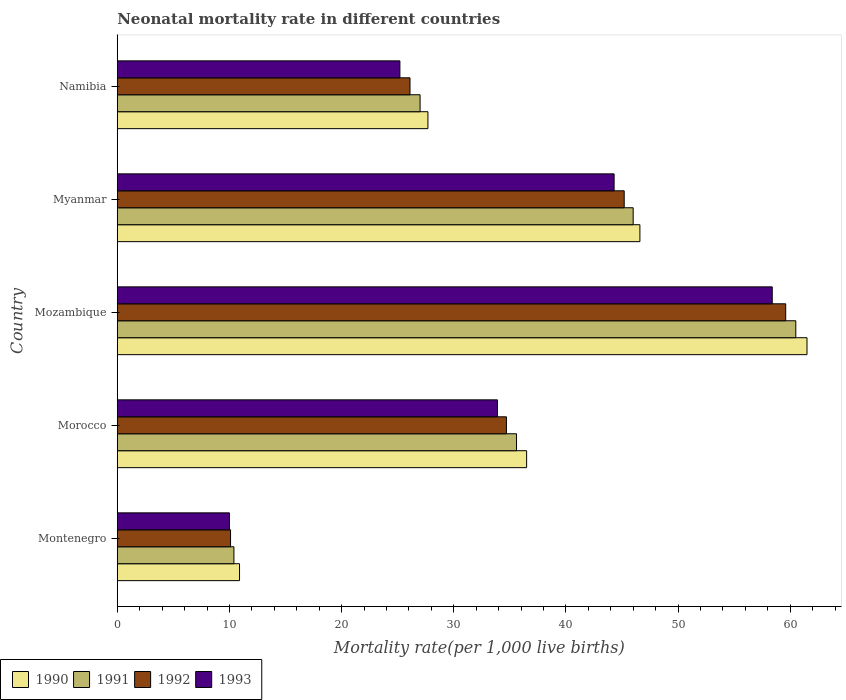How many different coloured bars are there?
Your answer should be very brief. 4. How many groups of bars are there?
Your answer should be compact. 5. Are the number of bars on each tick of the Y-axis equal?
Provide a short and direct response. Yes. How many bars are there on the 5th tick from the top?
Offer a terse response. 4. What is the label of the 4th group of bars from the top?
Ensure brevity in your answer.  Morocco. In how many cases, is the number of bars for a given country not equal to the number of legend labels?
Offer a very short reply. 0. What is the neonatal mortality rate in 1993 in Mozambique?
Ensure brevity in your answer.  58.4. Across all countries, what is the maximum neonatal mortality rate in 1990?
Ensure brevity in your answer.  61.5. Across all countries, what is the minimum neonatal mortality rate in 1993?
Provide a short and direct response. 10. In which country was the neonatal mortality rate in 1990 maximum?
Provide a succinct answer. Mozambique. In which country was the neonatal mortality rate in 1992 minimum?
Provide a short and direct response. Montenegro. What is the total neonatal mortality rate in 1993 in the graph?
Provide a short and direct response. 171.8. What is the difference between the neonatal mortality rate in 1991 in Myanmar and that in Namibia?
Make the answer very short. 19. What is the difference between the neonatal mortality rate in 1992 in Myanmar and the neonatal mortality rate in 1991 in Montenegro?
Your response must be concise. 34.8. What is the average neonatal mortality rate in 1991 per country?
Make the answer very short. 35.9. What is the difference between the neonatal mortality rate in 1993 and neonatal mortality rate in 1991 in Montenegro?
Your answer should be compact. -0.4. What is the ratio of the neonatal mortality rate in 1993 in Montenegro to that in Namibia?
Your answer should be compact. 0.4. Is the neonatal mortality rate in 1991 in Montenegro less than that in Namibia?
Ensure brevity in your answer.  Yes. Is the difference between the neonatal mortality rate in 1993 in Montenegro and Myanmar greater than the difference between the neonatal mortality rate in 1991 in Montenegro and Myanmar?
Your answer should be very brief. Yes. What is the difference between the highest and the second highest neonatal mortality rate in 1992?
Offer a very short reply. 14.4. What is the difference between the highest and the lowest neonatal mortality rate in 1991?
Offer a terse response. 50.1. Is the sum of the neonatal mortality rate in 1993 in Mozambique and Namibia greater than the maximum neonatal mortality rate in 1992 across all countries?
Offer a terse response. Yes. Is it the case that in every country, the sum of the neonatal mortality rate in 1990 and neonatal mortality rate in 1992 is greater than the sum of neonatal mortality rate in 1991 and neonatal mortality rate in 1993?
Your response must be concise. No. What does the 1st bar from the top in Namibia represents?
Provide a succinct answer. 1993. What does the 4th bar from the bottom in Mozambique represents?
Your answer should be very brief. 1993. Is it the case that in every country, the sum of the neonatal mortality rate in 1991 and neonatal mortality rate in 1990 is greater than the neonatal mortality rate in 1992?
Provide a succinct answer. Yes. How many bars are there?
Your response must be concise. 20. Are all the bars in the graph horizontal?
Ensure brevity in your answer.  Yes. What is the difference between two consecutive major ticks on the X-axis?
Offer a terse response. 10. Does the graph contain any zero values?
Offer a very short reply. No. Does the graph contain grids?
Your response must be concise. No. How many legend labels are there?
Your answer should be very brief. 4. How are the legend labels stacked?
Offer a terse response. Horizontal. What is the title of the graph?
Make the answer very short. Neonatal mortality rate in different countries. Does "1985" appear as one of the legend labels in the graph?
Offer a very short reply. No. What is the label or title of the X-axis?
Provide a succinct answer. Mortality rate(per 1,0 live births). What is the label or title of the Y-axis?
Keep it short and to the point. Country. What is the Mortality rate(per 1,000 live births) in 1990 in Montenegro?
Your answer should be compact. 10.9. What is the Mortality rate(per 1,000 live births) in 1992 in Montenegro?
Provide a short and direct response. 10.1. What is the Mortality rate(per 1,000 live births) of 1993 in Montenegro?
Your answer should be compact. 10. What is the Mortality rate(per 1,000 live births) in 1990 in Morocco?
Keep it short and to the point. 36.5. What is the Mortality rate(per 1,000 live births) in 1991 in Morocco?
Give a very brief answer. 35.6. What is the Mortality rate(per 1,000 live births) in 1992 in Morocco?
Your answer should be compact. 34.7. What is the Mortality rate(per 1,000 live births) of 1993 in Morocco?
Keep it short and to the point. 33.9. What is the Mortality rate(per 1,000 live births) in 1990 in Mozambique?
Your answer should be very brief. 61.5. What is the Mortality rate(per 1,000 live births) of 1991 in Mozambique?
Your response must be concise. 60.5. What is the Mortality rate(per 1,000 live births) in 1992 in Mozambique?
Your response must be concise. 59.6. What is the Mortality rate(per 1,000 live births) of 1993 in Mozambique?
Offer a very short reply. 58.4. What is the Mortality rate(per 1,000 live births) in 1990 in Myanmar?
Ensure brevity in your answer.  46.6. What is the Mortality rate(per 1,000 live births) in 1992 in Myanmar?
Provide a succinct answer. 45.2. What is the Mortality rate(per 1,000 live births) in 1993 in Myanmar?
Make the answer very short. 44.3. What is the Mortality rate(per 1,000 live births) in 1990 in Namibia?
Your answer should be compact. 27.7. What is the Mortality rate(per 1,000 live births) in 1991 in Namibia?
Give a very brief answer. 27. What is the Mortality rate(per 1,000 live births) of 1992 in Namibia?
Your answer should be very brief. 26.1. What is the Mortality rate(per 1,000 live births) in 1993 in Namibia?
Offer a very short reply. 25.2. Across all countries, what is the maximum Mortality rate(per 1,000 live births) of 1990?
Ensure brevity in your answer.  61.5. Across all countries, what is the maximum Mortality rate(per 1,000 live births) in 1991?
Your answer should be compact. 60.5. Across all countries, what is the maximum Mortality rate(per 1,000 live births) of 1992?
Your answer should be very brief. 59.6. Across all countries, what is the maximum Mortality rate(per 1,000 live births) in 1993?
Ensure brevity in your answer.  58.4. What is the total Mortality rate(per 1,000 live births) in 1990 in the graph?
Provide a short and direct response. 183.2. What is the total Mortality rate(per 1,000 live births) in 1991 in the graph?
Your answer should be very brief. 179.5. What is the total Mortality rate(per 1,000 live births) of 1992 in the graph?
Offer a terse response. 175.7. What is the total Mortality rate(per 1,000 live births) in 1993 in the graph?
Ensure brevity in your answer.  171.8. What is the difference between the Mortality rate(per 1,000 live births) in 1990 in Montenegro and that in Morocco?
Offer a very short reply. -25.6. What is the difference between the Mortality rate(per 1,000 live births) in 1991 in Montenegro and that in Morocco?
Ensure brevity in your answer.  -25.2. What is the difference between the Mortality rate(per 1,000 live births) of 1992 in Montenegro and that in Morocco?
Make the answer very short. -24.6. What is the difference between the Mortality rate(per 1,000 live births) of 1993 in Montenegro and that in Morocco?
Provide a succinct answer. -23.9. What is the difference between the Mortality rate(per 1,000 live births) in 1990 in Montenegro and that in Mozambique?
Give a very brief answer. -50.6. What is the difference between the Mortality rate(per 1,000 live births) of 1991 in Montenegro and that in Mozambique?
Ensure brevity in your answer.  -50.1. What is the difference between the Mortality rate(per 1,000 live births) of 1992 in Montenegro and that in Mozambique?
Ensure brevity in your answer.  -49.5. What is the difference between the Mortality rate(per 1,000 live births) of 1993 in Montenegro and that in Mozambique?
Your response must be concise. -48.4. What is the difference between the Mortality rate(per 1,000 live births) of 1990 in Montenegro and that in Myanmar?
Provide a succinct answer. -35.7. What is the difference between the Mortality rate(per 1,000 live births) in 1991 in Montenegro and that in Myanmar?
Offer a very short reply. -35.6. What is the difference between the Mortality rate(per 1,000 live births) of 1992 in Montenegro and that in Myanmar?
Your response must be concise. -35.1. What is the difference between the Mortality rate(per 1,000 live births) in 1993 in Montenegro and that in Myanmar?
Your answer should be very brief. -34.3. What is the difference between the Mortality rate(per 1,000 live births) of 1990 in Montenegro and that in Namibia?
Ensure brevity in your answer.  -16.8. What is the difference between the Mortality rate(per 1,000 live births) of 1991 in Montenegro and that in Namibia?
Provide a short and direct response. -16.6. What is the difference between the Mortality rate(per 1,000 live births) in 1993 in Montenegro and that in Namibia?
Provide a short and direct response. -15.2. What is the difference between the Mortality rate(per 1,000 live births) in 1990 in Morocco and that in Mozambique?
Keep it short and to the point. -25. What is the difference between the Mortality rate(per 1,000 live births) of 1991 in Morocco and that in Mozambique?
Offer a terse response. -24.9. What is the difference between the Mortality rate(per 1,000 live births) in 1992 in Morocco and that in Mozambique?
Make the answer very short. -24.9. What is the difference between the Mortality rate(per 1,000 live births) of 1993 in Morocco and that in Mozambique?
Your answer should be very brief. -24.5. What is the difference between the Mortality rate(per 1,000 live births) of 1991 in Morocco and that in Myanmar?
Provide a short and direct response. -10.4. What is the difference between the Mortality rate(per 1,000 live births) of 1992 in Morocco and that in Myanmar?
Provide a succinct answer. -10.5. What is the difference between the Mortality rate(per 1,000 live births) in 1993 in Morocco and that in Myanmar?
Your answer should be compact. -10.4. What is the difference between the Mortality rate(per 1,000 live births) in 1990 in Morocco and that in Namibia?
Ensure brevity in your answer.  8.8. What is the difference between the Mortality rate(per 1,000 live births) of 1991 in Morocco and that in Namibia?
Your answer should be compact. 8.6. What is the difference between the Mortality rate(per 1,000 live births) in 1992 in Morocco and that in Namibia?
Provide a succinct answer. 8.6. What is the difference between the Mortality rate(per 1,000 live births) of 1990 in Mozambique and that in Myanmar?
Your answer should be very brief. 14.9. What is the difference between the Mortality rate(per 1,000 live births) in 1991 in Mozambique and that in Myanmar?
Offer a terse response. 14.5. What is the difference between the Mortality rate(per 1,000 live births) of 1993 in Mozambique and that in Myanmar?
Offer a very short reply. 14.1. What is the difference between the Mortality rate(per 1,000 live births) of 1990 in Mozambique and that in Namibia?
Your answer should be compact. 33.8. What is the difference between the Mortality rate(per 1,000 live births) in 1991 in Mozambique and that in Namibia?
Provide a short and direct response. 33.5. What is the difference between the Mortality rate(per 1,000 live births) in 1992 in Mozambique and that in Namibia?
Provide a succinct answer. 33.5. What is the difference between the Mortality rate(per 1,000 live births) of 1993 in Mozambique and that in Namibia?
Your answer should be very brief. 33.2. What is the difference between the Mortality rate(per 1,000 live births) in 1990 in Myanmar and that in Namibia?
Your answer should be compact. 18.9. What is the difference between the Mortality rate(per 1,000 live births) in 1991 in Myanmar and that in Namibia?
Ensure brevity in your answer.  19. What is the difference between the Mortality rate(per 1,000 live births) in 1993 in Myanmar and that in Namibia?
Your response must be concise. 19.1. What is the difference between the Mortality rate(per 1,000 live births) in 1990 in Montenegro and the Mortality rate(per 1,000 live births) in 1991 in Morocco?
Give a very brief answer. -24.7. What is the difference between the Mortality rate(per 1,000 live births) of 1990 in Montenegro and the Mortality rate(per 1,000 live births) of 1992 in Morocco?
Your answer should be compact. -23.8. What is the difference between the Mortality rate(per 1,000 live births) in 1991 in Montenegro and the Mortality rate(per 1,000 live births) in 1992 in Morocco?
Provide a short and direct response. -24.3. What is the difference between the Mortality rate(per 1,000 live births) of 1991 in Montenegro and the Mortality rate(per 1,000 live births) of 1993 in Morocco?
Ensure brevity in your answer.  -23.5. What is the difference between the Mortality rate(per 1,000 live births) in 1992 in Montenegro and the Mortality rate(per 1,000 live births) in 1993 in Morocco?
Make the answer very short. -23.8. What is the difference between the Mortality rate(per 1,000 live births) of 1990 in Montenegro and the Mortality rate(per 1,000 live births) of 1991 in Mozambique?
Make the answer very short. -49.6. What is the difference between the Mortality rate(per 1,000 live births) of 1990 in Montenegro and the Mortality rate(per 1,000 live births) of 1992 in Mozambique?
Your answer should be very brief. -48.7. What is the difference between the Mortality rate(per 1,000 live births) in 1990 in Montenegro and the Mortality rate(per 1,000 live births) in 1993 in Mozambique?
Provide a short and direct response. -47.5. What is the difference between the Mortality rate(per 1,000 live births) in 1991 in Montenegro and the Mortality rate(per 1,000 live births) in 1992 in Mozambique?
Ensure brevity in your answer.  -49.2. What is the difference between the Mortality rate(per 1,000 live births) in 1991 in Montenegro and the Mortality rate(per 1,000 live births) in 1993 in Mozambique?
Offer a very short reply. -48. What is the difference between the Mortality rate(per 1,000 live births) of 1992 in Montenegro and the Mortality rate(per 1,000 live births) of 1993 in Mozambique?
Offer a very short reply. -48.3. What is the difference between the Mortality rate(per 1,000 live births) of 1990 in Montenegro and the Mortality rate(per 1,000 live births) of 1991 in Myanmar?
Give a very brief answer. -35.1. What is the difference between the Mortality rate(per 1,000 live births) of 1990 in Montenegro and the Mortality rate(per 1,000 live births) of 1992 in Myanmar?
Offer a very short reply. -34.3. What is the difference between the Mortality rate(per 1,000 live births) in 1990 in Montenegro and the Mortality rate(per 1,000 live births) in 1993 in Myanmar?
Your answer should be compact. -33.4. What is the difference between the Mortality rate(per 1,000 live births) of 1991 in Montenegro and the Mortality rate(per 1,000 live births) of 1992 in Myanmar?
Your answer should be very brief. -34.8. What is the difference between the Mortality rate(per 1,000 live births) of 1991 in Montenegro and the Mortality rate(per 1,000 live births) of 1993 in Myanmar?
Your response must be concise. -33.9. What is the difference between the Mortality rate(per 1,000 live births) of 1992 in Montenegro and the Mortality rate(per 1,000 live births) of 1993 in Myanmar?
Give a very brief answer. -34.2. What is the difference between the Mortality rate(per 1,000 live births) of 1990 in Montenegro and the Mortality rate(per 1,000 live births) of 1991 in Namibia?
Ensure brevity in your answer.  -16.1. What is the difference between the Mortality rate(per 1,000 live births) of 1990 in Montenegro and the Mortality rate(per 1,000 live births) of 1992 in Namibia?
Your answer should be very brief. -15.2. What is the difference between the Mortality rate(per 1,000 live births) of 1990 in Montenegro and the Mortality rate(per 1,000 live births) of 1993 in Namibia?
Your answer should be very brief. -14.3. What is the difference between the Mortality rate(per 1,000 live births) of 1991 in Montenegro and the Mortality rate(per 1,000 live births) of 1992 in Namibia?
Give a very brief answer. -15.7. What is the difference between the Mortality rate(per 1,000 live births) of 1991 in Montenegro and the Mortality rate(per 1,000 live births) of 1993 in Namibia?
Offer a very short reply. -14.8. What is the difference between the Mortality rate(per 1,000 live births) in 1992 in Montenegro and the Mortality rate(per 1,000 live births) in 1993 in Namibia?
Your response must be concise. -15.1. What is the difference between the Mortality rate(per 1,000 live births) in 1990 in Morocco and the Mortality rate(per 1,000 live births) in 1991 in Mozambique?
Make the answer very short. -24. What is the difference between the Mortality rate(per 1,000 live births) of 1990 in Morocco and the Mortality rate(per 1,000 live births) of 1992 in Mozambique?
Your answer should be very brief. -23.1. What is the difference between the Mortality rate(per 1,000 live births) of 1990 in Morocco and the Mortality rate(per 1,000 live births) of 1993 in Mozambique?
Your answer should be compact. -21.9. What is the difference between the Mortality rate(per 1,000 live births) in 1991 in Morocco and the Mortality rate(per 1,000 live births) in 1992 in Mozambique?
Make the answer very short. -24. What is the difference between the Mortality rate(per 1,000 live births) of 1991 in Morocco and the Mortality rate(per 1,000 live births) of 1993 in Mozambique?
Offer a terse response. -22.8. What is the difference between the Mortality rate(per 1,000 live births) in 1992 in Morocco and the Mortality rate(per 1,000 live births) in 1993 in Mozambique?
Give a very brief answer. -23.7. What is the difference between the Mortality rate(per 1,000 live births) of 1990 in Morocco and the Mortality rate(per 1,000 live births) of 1992 in Myanmar?
Keep it short and to the point. -8.7. What is the difference between the Mortality rate(per 1,000 live births) in 1991 in Morocco and the Mortality rate(per 1,000 live births) in 1993 in Myanmar?
Your response must be concise. -8.7. What is the difference between the Mortality rate(per 1,000 live births) of 1992 in Morocco and the Mortality rate(per 1,000 live births) of 1993 in Myanmar?
Make the answer very short. -9.6. What is the difference between the Mortality rate(per 1,000 live births) of 1990 in Morocco and the Mortality rate(per 1,000 live births) of 1991 in Namibia?
Offer a very short reply. 9.5. What is the difference between the Mortality rate(per 1,000 live births) of 1990 in Morocco and the Mortality rate(per 1,000 live births) of 1992 in Namibia?
Provide a short and direct response. 10.4. What is the difference between the Mortality rate(per 1,000 live births) in 1990 in Morocco and the Mortality rate(per 1,000 live births) in 1993 in Namibia?
Keep it short and to the point. 11.3. What is the difference between the Mortality rate(per 1,000 live births) of 1991 in Morocco and the Mortality rate(per 1,000 live births) of 1993 in Namibia?
Your answer should be very brief. 10.4. What is the difference between the Mortality rate(per 1,000 live births) in 1992 in Morocco and the Mortality rate(per 1,000 live births) in 1993 in Namibia?
Keep it short and to the point. 9.5. What is the difference between the Mortality rate(per 1,000 live births) in 1990 in Mozambique and the Mortality rate(per 1,000 live births) in 1992 in Myanmar?
Offer a terse response. 16.3. What is the difference between the Mortality rate(per 1,000 live births) of 1991 in Mozambique and the Mortality rate(per 1,000 live births) of 1992 in Myanmar?
Provide a succinct answer. 15.3. What is the difference between the Mortality rate(per 1,000 live births) in 1992 in Mozambique and the Mortality rate(per 1,000 live births) in 1993 in Myanmar?
Your answer should be very brief. 15.3. What is the difference between the Mortality rate(per 1,000 live births) of 1990 in Mozambique and the Mortality rate(per 1,000 live births) of 1991 in Namibia?
Offer a terse response. 34.5. What is the difference between the Mortality rate(per 1,000 live births) of 1990 in Mozambique and the Mortality rate(per 1,000 live births) of 1992 in Namibia?
Your answer should be compact. 35.4. What is the difference between the Mortality rate(per 1,000 live births) of 1990 in Mozambique and the Mortality rate(per 1,000 live births) of 1993 in Namibia?
Your response must be concise. 36.3. What is the difference between the Mortality rate(per 1,000 live births) of 1991 in Mozambique and the Mortality rate(per 1,000 live births) of 1992 in Namibia?
Ensure brevity in your answer.  34.4. What is the difference between the Mortality rate(per 1,000 live births) of 1991 in Mozambique and the Mortality rate(per 1,000 live births) of 1993 in Namibia?
Make the answer very short. 35.3. What is the difference between the Mortality rate(per 1,000 live births) in 1992 in Mozambique and the Mortality rate(per 1,000 live births) in 1993 in Namibia?
Give a very brief answer. 34.4. What is the difference between the Mortality rate(per 1,000 live births) in 1990 in Myanmar and the Mortality rate(per 1,000 live births) in 1991 in Namibia?
Offer a terse response. 19.6. What is the difference between the Mortality rate(per 1,000 live births) in 1990 in Myanmar and the Mortality rate(per 1,000 live births) in 1993 in Namibia?
Your answer should be very brief. 21.4. What is the difference between the Mortality rate(per 1,000 live births) in 1991 in Myanmar and the Mortality rate(per 1,000 live births) in 1993 in Namibia?
Offer a terse response. 20.8. What is the average Mortality rate(per 1,000 live births) in 1990 per country?
Your answer should be compact. 36.64. What is the average Mortality rate(per 1,000 live births) in 1991 per country?
Offer a terse response. 35.9. What is the average Mortality rate(per 1,000 live births) in 1992 per country?
Offer a terse response. 35.14. What is the average Mortality rate(per 1,000 live births) of 1993 per country?
Make the answer very short. 34.36. What is the difference between the Mortality rate(per 1,000 live births) of 1990 and Mortality rate(per 1,000 live births) of 1991 in Montenegro?
Provide a succinct answer. 0.5. What is the difference between the Mortality rate(per 1,000 live births) of 1990 and Mortality rate(per 1,000 live births) of 1993 in Montenegro?
Provide a short and direct response. 0.9. What is the difference between the Mortality rate(per 1,000 live births) of 1991 and Mortality rate(per 1,000 live births) of 1992 in Montenegro?
Provide a short and direct response. 0.3. What is the difference between the Mortality rate(per 1,000 live births) in 1992 and Mortality rate(per 1,000 live births) in 1993 in Montenegro?
Give a very brief answer. 0.1. What is the difference between the Mortality rate(per 1,000 live births) in 1990 and Mortality rate(per 1,000 live births) in 1991 in Morocco?
Provide a short and direct response. 0.9. What is the difference between the Mortality rate(per 1,000 live births) of 1990 and Mortality rate(per 1,000 live births) of 1992 in Morocco?
Your answer should be compact. 1.8. What is the difference between the Mortality rate(per 1,000 live births) in 1990 and Mortality rate(per 1,000 live births) in 1993 in Morocco?
Offer a terse response. 2.6. What is the difference between the Mortality rate(per 1,000 live births) in 1991 and Mortality rate(per 1,000 live births) in 1993 in Morocco?
Your answer should be very brief. 1.7. What is the difference between the Mortality rate(per 1,000 live births) in 1992 and Mortality rate(per 1,000 live births) in 1993 in Morocco?
Offer a very short reply. 0.8. What is the difference between the Mortality rate(per 1,000 live births) in 1990 and Mortality rate(per 1,000 live births) in 1993 in Mozambique?
Make the answer very short. 3.1. What is the difference between the Mortality rate(per 1,000 live births) in 1992 and Mortality rate(per 1,000 live births) in 1993 in Mozambique?
Provide a succinct answer. 1.2. What is the difference between the Mortality rate(per 1,000 live births) of 1990 and Mortality rate(per 1,000 live births) of 1991 in Myanmar?
Offer a very short reply. 0.6. What is the difference between the Mortality rate(per 1,000 live births) of 1990 and Mortality rate(per 1,000 live births) of 1992 in Myanmar?
Ensure brevity in your answer.  1.4. What is the difference between the Mortality rate(per 1,000 live births) in 1992 and Mortality rate(per 1,000 live births) in 1993 in Myanmar?
Offer a terse response. 0.9. What is the difference between the Mortality rate(per 1,000 live births) of 1991 and Mortality rate(per 1,000 live births) of 1993 in Namibia?
Provide a short and direct response. 1.8. What is the ratio of the Mortality rate(per 1,000 live births) of 1990 in Montenegro to that in Morocco?
Your response must be concise. 0.3. What is the ratio of the Mortality rate(per 1,000 live births) in 1991 in Montenegro to that in Morocco?
Give a very brief answer. 0.29. What is the ratio of the Mortality rate(per 1,000 live births) in 1992 in Montenegro to that in Morocco?
Keep it short and to the point. 0.29. What is the ratio of the Mortality rate(per 1,000 live births) in 1993 in Montenegro to that in Morocco?
Keep it short and to the point. 0.29. What is the ratio of the Mortality rate(per 1,000 live births) of 1990 in Montenegro to that in Mozambique?
Your response must be concise. 0.18. What is the ratio of the Mortality rate(per 1,000 live births) of 1991 in Montenegro to that in Mozambique?
Your response must be concise. 0.17. What is the ratio of the Mortality rate(per 1,000 live births) of 1992 in Montenegro to that in Mozambique?
Your answer should be very brief. 0.17. What is the ratio of the Mortality rate(per 1,000 live births) in 1993 in Montenegro to that in Mozambique?
Your response must be concise. 0.17. What is the ratio of the Mortality rate(per 1,000 live births) of 1990 in Montenegro to that in Myanmar?
Offer a very short reply. 0.23. What is the ratio of the Mortality rate(per 1,000 live births) in 1991 in Montenegro to that in Myanmar?
Ensure brevity in your answer.  0.23. What is the ratio of the Mortality rate(per 1,000 live births) in 1992 in Montenegro to that in Myanmar?
Give a very brief answer. 0.22. What is the ratio of the Mortality rate(per 1,000 live births) of 1993 in Montenegro to that in Myanmar?
Your answer should be compact. 0.23. What is the ratio of the Mortality rate(per 1,000 live births) of 1990 in Montenegro to that in Namibia?
Make the answer very short. 0.39. What is the ratio of the Mortality rate(per 1,000 live births) in 1991 in Montenegro to that in Namibia?
Your answer should be very brief. 0.39. What is the ratio of the Mortality rate(per 1,000 live births) in 1992 in Montenegro to that in Namibia?
Provide a short and direct response. 0.39. What is the ratio of the Mortality rate(per 1,000 live births) of 1993 in Montenegro to that in Namibia?
Give a very brief answer. 0.4. What is the ratio of the Mortality rate(per 1,000 live births) in 1990 in Morocco to that in Mozambique?
Offer a very short reply. 0.59. What is the ratio of the Mortality rate(per 1,000 live births) in 1991 in Morocco to that in Mozambique?
Provide a short and direct response. 0.59. What is the ratio of the Mortality rate(per 1,000 live births) of 1992 in Morocco to that in Mozambique?
Keep it short and to the point. 0.58. What is the ratio of the Mortality rate(per 1,000 live births) in 1993 in Morocco to that in Mozambique?
Ensure brevity in your answer.  0.58. What is the ratio of the Mortality rate(per 1,000 live births) in 1990 in Morocco to that in Myanmar?
Give a very brief answer. 0.78. What is the ratio of the Mortality rate(per 1,000 live births) in 1991 in Morocco to that in Myanmar?
Provide a short and direct response. 0.77. What is the ratio of the Mortality rate(per 1,000 live births) of 1992 in Morocco to that in Myanmar?
Provide a succinct answer. 0.77. What is the ratio of the Mortality rate(per 1,000 live births) in 1993 in Morocco to that in Myanmar?
Your answer should be compact. 0.77. What is the ratio of the Mortality rate(per 1,000 live births) in 1990 in Morocco to that in Namibia?
Make the answer very short. 1.32. What is the ratio of the Mortality rate(per 1,000 live births) in 1991 in Morocco to that in Namibia?
Make the answer very short. 1.32. What is the ratio of the Mortality rate(per 1,000 live births) in 1992 in Morocco to that in Namibia?
Offer a terse response. 1.33. What is the ratio of the Mortality rate(per 1,000 live births) of 1993 in Morocco to that in Namibia?
Your response must be concise. 1.35. What is the ratio of the Mortality rate(per 1,000 live births) of 1990 in Mozambique to that in Myanmar?
Your answer should be compact. 1.32. What is the ratio of the Mortality rate(per 1,000 live births) in 1991 in Mozambique to that in Myanmar?
Ensure brevity in your answer.  1.32. What is the ratio of the Mortality rate(per 1,000 live births) of 1992 in Mozambique to that in Myanmar?
Offer a terse response. 1.32. What is the ratio of the Mortality rate(per 1,000 live births) in 1993 in Mozambique to that in Myanmar?
Provide a short and direct response. 1.32. What is the ratio of the Mortality rate(per 1,000 live births) of 1990 in Mozambique to that in Namibia?
Your response must be concise. 2.22. What is the ratio of the Mortality rate(per 1,000 live births) in 1991 in Mozambique to that in Namibia?
Your response must be concise. 2.24. What is the ratio of the Mortality rate(per 1,000 live births) in 1992 in Mozambique to that in Namibia?
Give a very brief answer. 2.28. What is the ratio of the Mortality rate(per 1,000 live births) in 1993 in Mozambique to that in Namibia?
Offer a very short reply. 2.32. What is the ratio of the Mortality rate(per 1,000 live births) in 1990 in Myanmar to that in Namibia?
Your answer should be very brief. 1.68. What is the ratio of the Mortality rate(per 1,000 live births) of 1991 in Myanmar to that in Namibia?
Ensure brevity in your answer.  1.7. What is the ratio of the Mortality rate(per 1,000 live births) of 1992 in Myanmar to that in Namibia?
Your response must be concise. 1.73. What is the ratio of the Mortality rate(per 1,000 live births) in 1993 in Myanmar to that in Namibia?
Provide a succinct answer. 1.76. What is the difference between the highest and the second highest Mortality rate(per 1,000 live births) in 1991?
Keep it short and to the point. 14.5. What is the difference between the highest and the second highest Mortality rate(per 1,000 live births) in 1993?
Your answer should be very brief. 14.1. What is the difference between the highest and the lowest Mortality rate(per 1,000 live births) of 1990?
Provide a short and direct response. 50.6. What is the difference between the highest and the lowest Mortality rate(per 1,000 live births) in 1991?
Your answer should be compact. 50.1. What is the difference between the highest and the lowest Mortality rate(per 1,000 live births) of 1992?
Offer a terse response. 49.5. What is the difference between the highest and the lowest Mortality rate(per 1,000 live births) of 1993?
Your answer should be very brief. 48.4. 